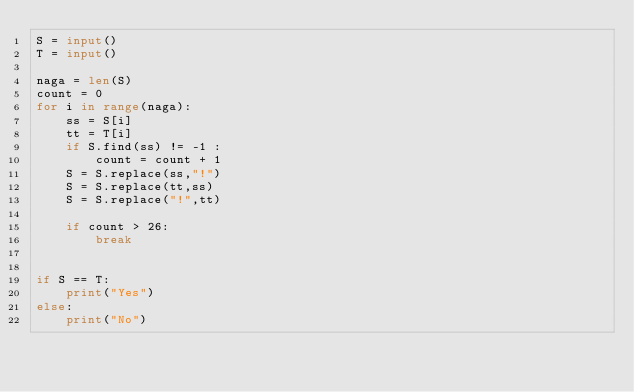<code> <loc_0><loc_0><loc_500><loc_500><_Python_>S = input()
T = input()

naga = len(S)
count = 0
for i in range(naga):
    ss = S[i]
    tt = T[i]
    if S.find(ss) != -1 :
        count = count + 1
    S = S.replace(ss,"!")
    S = S.replace(tt,ss)
    S = S.replace("!",tt)

    if count > 26:
        break


if S == T:
    print("Yes")
else:
    print("No")
</code> 